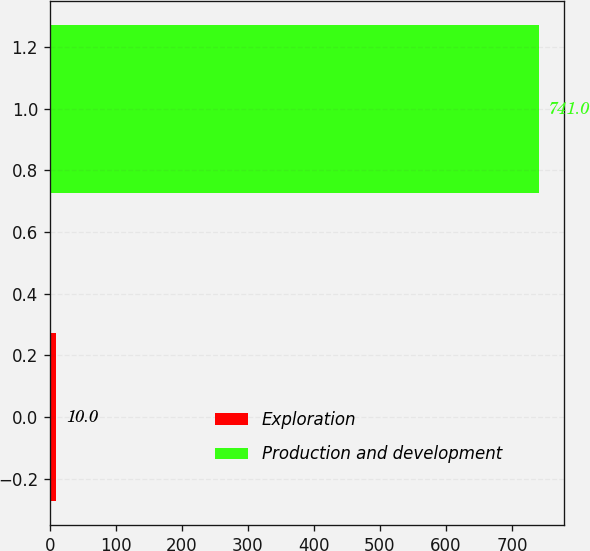Convert chart. <chart><loc_0><loc_0><loc_500><loc_500><bar_chart><fcel>Exploration<fcel>Production and development<nl><fcel>10<fcel>741<nl></chart> 